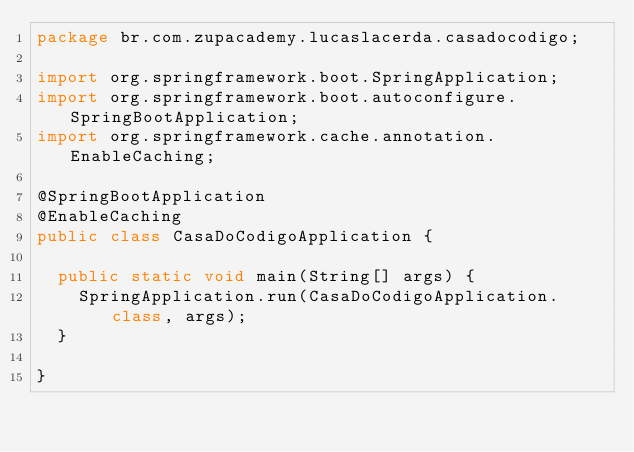<code> <loc_0><loc_0><loc_500><loc_500><_Java_>package br.com.zupacademy.lucaslacerda.casadocodigo;

import org.springframework.boot.SpringApplication;
import org.springframework.boot.autoconfigure.SpringBootApplication;
import org.springframework.cache.annotation.EnableCaching;

@SpringBootApplication
@EnableCaching
public class CasaDoCodigoApplication {

	public static void main(String[] args) {
		SpringApplication.run(CasaDoCodigoApplication.class, args);
	}

}
</code> 